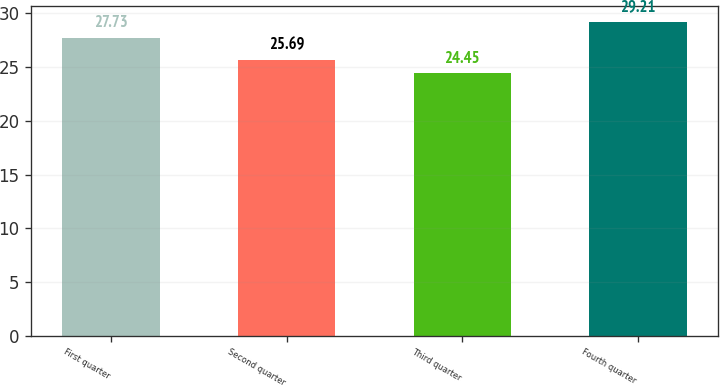Convert chart to OTSL. <chart><loc_0><loc_0><loc_500><loc_500><bar_chart><fcel>First quarter<fcel>Second quarter<fcel>Third quarter<fcel>Fourth quarter<nl><fcel>27.73<fcel>25.69<fcel>24.45<fcel>29.21<nl></chart> 